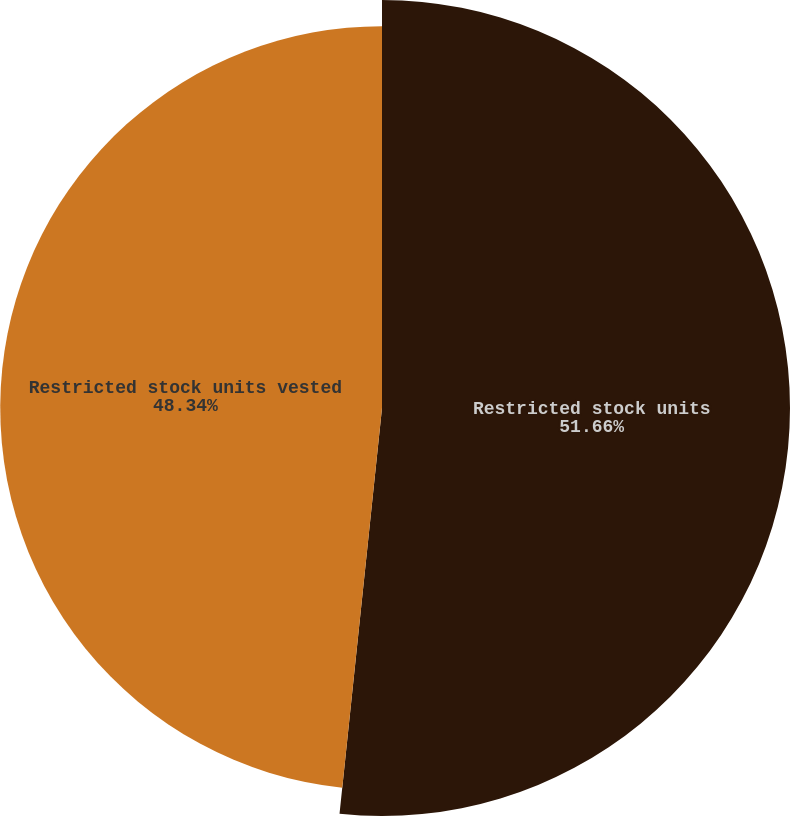Convert chart. <chart><loc_0><loc_0><loc_500><loc_500><pie_chart><fcel>Restricted stock units<fcel>Restricted stock units vested<nl><fcel>51.66%<fcel>48.34%<nl></chart> 